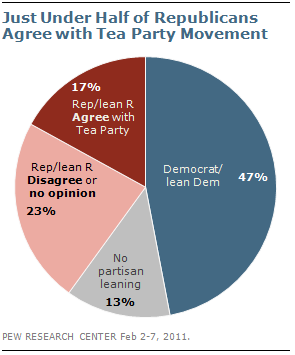Point out several critical features in this image. The percentage of democrats is [47], and the percentage with no partisan leaning is [13]. The red segment represents 0.17% of the total length. 